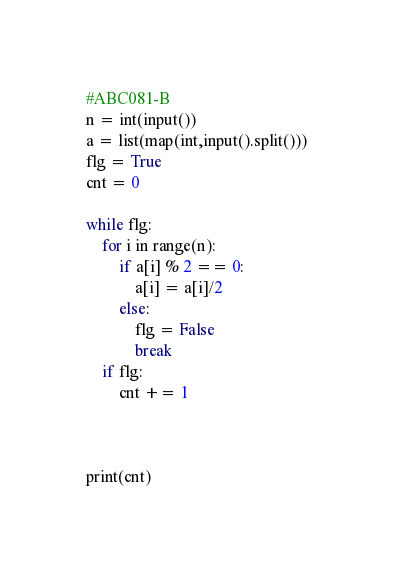<code> <loc_0><loc_0><loc_500><loc_500><_Python_>#ABC081-B
n = int(input())
a = list(map(int,input().split()))
flg = True
cnt = 0

while flg:
    for i in range(n):
        if a[i] % 2 == 0: 
            a[i] = a[i]/2
        else:
            flg = False
            break
    if flg:
        cnt += 1
    

            
print(cnt)</code> 